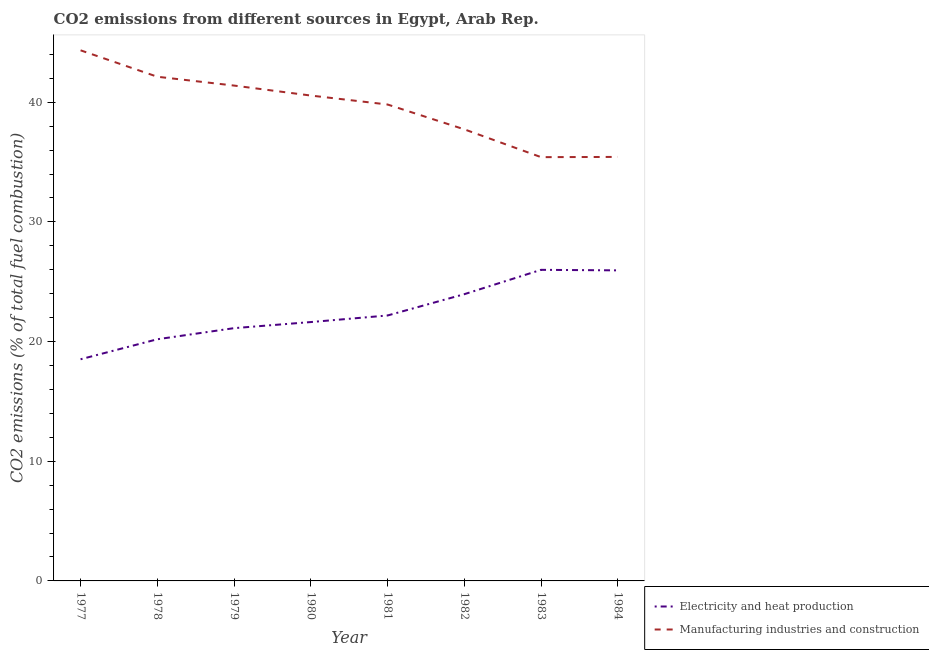Is the number of lines equal to the number of legend labels?
Offer a very short reply. Yes. What is the co2 emissions due to manufacturing industries in 1984?
Give a very brief answer. 35.43. Across all years, what is the maximum co2 emissions due to manufacturing industries?
Make the answer very short. 44.34. Across all years, what is the minimum co2 emissions due to electricity and heat production?
Your answer should be compact. 18.52. In which year was the co2 emissions due to manufacturing industries maximum?
Keep it short and to the point. 1977. What is the total co2 emissions due to electricity and heat production in the graph?
Your answer should be very brief. 179.56. What is the difference between the co2 emissions due to electricity and heat production in 1979 and that in 1982?
Your answer should be very brief. -2.84. What is the difference between the co2 emissions due to electricity and heat production in 1979 and the co2 emissions due to manufacturing industries in 1978?
Give a very brief answer. -21.01. What is the average co2 emissions due to manufacturing industries per year?
Your answer should be compact. 39.6. In the year 1978, what is the difference between the co2 emissions due to electricity and heat production and co2 emissions due to manufacturing industries?
Your answer should be very brief. -21.94. In how many years, is the co2 emissions due to electricity and heat production greater than 36 %?
Keep it short and to the point. 0. What is the ratio of the co2 emissions due to manufacturing industries in 1977 to that in 1979?
Keep it short and to the point. 1.07. Is the difference between the co2 emissions due to manufacturing industries in 1977 and 1978 greater than the difference between the co2 emissions due to electricity and heat production in 1977 and 1978?
Provide a short and direct response. Yes. What is the difference between the highest and the second highest co2 emissions due to electricity and heat production?
Make the answer very short. 0.04. What is the difference between the highest and the lowest co2 emissions due to electricity and heat production?
Make the answer very short. 7.47. In how many years, is the co2 emissions due to manufacturing industries greater than the average co2 emissions due to manufacturing industries taken over all years?
Give a very brief answer. 5. Is the sum of the co2 emissions due to electricity and heat production in 1977 and 1983 greater than the maximum co2 emissions due to manufacturing industries across all years?
Give a very brief answer. Yes. Does the co2 emissions due to manufacturing industries monotonically increase over the years?
Provide a short and direct response. No. Is the co2 emissions due to electricity and heat production strictly greater than the co2 emissions due to manufacturing industries over the years?
Offer a very short reply. No. How many lines are there?
Give a very brief answer. 2. How many years are there in the graph?
Your answer should be very brief. 8. What is the difference between two consecutive major ticks on the Y-axis?
Your answer should be compact. 10. Are the values on the major ticks of Y-axis written in scientific E-notation?
Your answer should be compact. No. Where does the legend appear in the graph?
Offer a very short reply. Bottom right. How are the legend labels stacked?
Your answer should be very brief. Vertical. What is the title of the graph?
Ensure brevity in your answer.  CO2 emissions from different sources in Egypt, Arab Rep. Does "Highest 20% of population" appear as one of the legend labels in the graph?
Give a very brief answer. No. What is the label or title of the Y-axis?
Provide a short and direct response. CO2 emissions (% of total fuel combustion). What is the CO2 emissions (% of total fuel combustion) in Electricity and heat production in 1977?
Your response must be concise. 18.52. What is the CO2 emissions (% of total fuel combustion) in Manufacturing industries and construction in 1977?
Your answer should be compact. 44.34. What is the CO2 emissions (% of total fuel combustion) of Electricity and heat production in 1978?
Your answer should be very brief. 20.19. What is the CO2 emissions (% of total fuel combustion) in Manufacturing industries and construction in 1978?
Your answer should be very brief. 42.13. What is the CO2 emissions (% of total fuel combustion) of Electricity and heat production in 1979?
Keep it short and to the point. 21.12. What is the CO2 emissions (% of total fuel combustion) in Manufacturing industries and construction in 1979?
Offer a very short reply. 41.39. What is the CO2 emissions (% of total fuel combustion) in Electricity and heat production in 1980?
Give a very brief answer. 21.63. What is the CO2 emissions (% of total fuel combustion) of Manufacturing industries and construction in 1980?
Your answer should be compact. 40.56. What is the CO2 emissions (% of total fuel combustion) in Electricity and heat production in 1981?
Your answer should be very brief. 22.18. What is the CO2 emissions (% of total fuel combustion) of Manufacturing industries and construction in 1981?
Provide a succinct answer. 39.81. What is the CO2 emissions (% of total fuel combustion) in Electricity and heat production in 1982?
Provide a short and direct response. 23.96. What is the CO2 emissions (% of total fuel combustion) in Manufacturing industries and construction in 1982?
Ensure brevity in your answer.  37.74. What is the CO2 emissions (% of total fuel combustion) in Electricity and heat production in 1983?
Ensure brevity in your answer.  26. What is the CO2 emissions (% of total fuel combustion) of Manufacturing industries and construction in 1983?
Keep it short and to the point. 35.41. What is the CO2 emissions (% of total fuel combustion) in Electricity and heat production in 1984?
Your answer should be compact. 25.95. What is the CO2 emissions (% of total fuel combustion) of Manufacturing industries and construction in 1984?
Make the answer very short. 35.43. Across all years, what is the maximum CO2 emissions (% of total fuel combustion) in Electricity and heat production?
Provide a succinct answer. 26. Across all years, what is the maximum CO2 emissions (% of total fuel combustion) in Manufacturing industries and construction?
Keep it short and to the point. 44.34. Across all years, what is the minimum CO2 emissions (% of total fuel combustion) in Electricity and heat production?
Offer a very short reply. 18.52. Across all years, what is the minimum CO2 emissions (% of total fuel combustion) of Manufacturing industries and construction?
Provide a short and direct response. 35.41. What is the total CO2 emissions (% of total fuel combustion) in Electricity and heat production in the graph?
Your answer should be very brief. 179.56. What is the total CO2 emissions (% of total fuel combustion) of Manufacturing industries and construction in the graph?
Make the answer very short. 316.82. What is the difference between the CO2 emissions (% of total fuel combustion) of Electricity and heat production in 1977 and that in 1978?
Give a very brief answer. -1.67. What is the difference between the CO2 emissions (% of total fuel combustion) in Manufacturing industries and construction in 1977 and that in 1978?
Offer a very short reply. 2.21. What is the difference between the CO2 emissions (% of total fuel combustion) in Electricity and heat production in 1977 and that in 1979?
Offer a terse response. -2.6. What is the difference between the CO2 emissions (% of total fuel combustion) of Manufacturing industries and construction in 1977 and that in 1979?
Offer a very short reply. 2.95. What is the difference between the CO2 emissions (% of total fuel combustion) in Electricity and heat production in 1977 and that in 1980?
Offer a terse response. -3.11. What is the difference between the CO2 emissions (% of total fuel combustion) of Manufacturing industries and construction in 1977 and that in 1980?
Give a very brief answer. 3.78. What is the difference between the CO2 emissions (% of total fuel combustion) in Electricity and heat production in 1977 and that in 1981?
Your answer should be very brief. -3.66. What is the difference between the CO2 emissions (% of total fuel combustion) in Manufacturing industries and construction in 1977 and that in 1981?
Ensure brevity in your answer.  4.53. What is the difference between the CO2 emissions (% of total fuel combustion) of Electricity and heat production in 1977 and that in 1982?
Ensure brevity in your answer.  -5.44. What is the difference between the CO2 emissions (% of total fuel combustion) in Manufacturing industries and construction in 1977 and that in 1982?
Give a very brief answer. 6.6. What is the difference between the CO2 emissions (% of total fuel combustion) in Electricity and heat production in 1977 and that in 1983?
Your answer should be compact. -7.47. What is the difference between the CO2 emissions (% of total fuel combustion) in Manufacturing industries and construction in 1977 and that in 1983?
Give a very brief answer. 8.93. What is the difference between the CO2 emissions (% of total fuel combustion) of Electricity and heat production in 1977 and that in 1984?
Your answer should be very brief. -7.43. What is the difference between the CO2 emissions (% of total fuel combustion) in Manufacturing industries and construction in 1977 and that in 1984?
Keep it short and to the point. 8.91. What is the difference between the CO2 emissions (% of total fuel combustion) of Electricity and heat production in 1978 and that in 1979?
Offer a terse response. -0.93. What is the difference between the CO2 emissions (% of total fuel combustion) in Manufacturing industries and construction in 1978 and that in 1979?
Provide a succinct answer. 0.74. What is the difference between the CO2 emissions (% of total fuel combustion) in Electricity and heat production in 1978 and that in 1980?
Make the answer very short. -1.44. What is the difference between the CO2 emissions (% of total fuel combustion) in Manufacturing industries and construction in 1978 and that in 1980?
Keep it short and to the point. 1.57. What is the difference between the CO2 emissions (% of total fuel combustion) of Electricity and heat production in 1978 and that in 1981?
Ensure brevity in your answer.  -1.99. What is the difference between the CO2 emissions (% of total fuel combustion) of Manufacturing industries and construction in 1978 and that in 1981?
Provide a short and direct response. 2.32. What is the difference between the CO2 emissions (% of total fuel combustion) in Electricity and heat production in 1978 and that in 1982?
Your answer should be very brief. -3.77. What is the difference between the CO2 emissions (% of total fuel combustion) of Manufacturing industries and construction in 1978 and that in 1982?
Give a very brief answer. 4.4. What is the difference between the CO2 emissions (% of total fuel combustion) of Electricity and heat production in 1978 and that in 1983?
Give a very brief answer. -5.8. What is the difference between the CO2 emissions (% of total fuel combustion) in Manufacturing industries and construction in 1978 and that in 1983?
Offer a very short reply. 6.72. What is the difference between the CO2 emissions (% of total fuel combustion) in Electricity and heat production in 1978 and that in 1984?
Give a very brief answer. -5.76. What is the difference between the CO2 emissions (% of total fuel combustion) in Manufacturing industries and construction in 1978 and that in 1984?
Your response must be concise. 6.7. What is the difference between the CO2 emissions (% of total fuel combustion) in Electricity and heat production in 1979 and that in 1980?
Your response must be concise. -0.51. What is the difference between the CO2 emissions (% of total fuel combustion) in Manufacturing industries and construction in 1979 and that in 1980?
Make the answer very short. 0.83. What is the difference between the CO2 emissions (% of total fuel combustion) of Electricity and heat production in 1979 and that in 1981?
Offer a very short reply. -1.06. What is the difference between the CO2 emissions (% of total fuel combustion) of Manufacturing industries and construction in 1979 and that in 1981?
Give a very brief answer. 1.58. What is the difference between the CO2 emissions (% of total fuel combustion) of Electricity and heat production in 1979 and that in 1982?
Offer a terse response. -2.84. What is the difference between the CO2 emissions (% of total fuel combustion) of Manufacturing industries and construction in 1979 and that in 1982?
Your answer should be very brief. 3.66. What is the difference between the CO2 emissions (% of total fuel combustion) in Electricity and heat production in 1979 and that in 1983?
Your answer should be very brief. -4.87. What is the difference between the CO2 emissions (% of total fuel combustion) of Manufacturing industries and construction in 1979 and that in 1983?
Make the answer very short. 5.98. What is the difference between the CO2 emissions (% of total fuel combustion) of Electricity and heat production in 1979 and that in 1984?
Offer a terse response. -4.83. What is the difference between the CO2 emissions (% of total fuel combustion) of Manufacturing industries and construction in 1979 and that in 1984?
Offer a very short reply. 5.96. What is the difference between the CO2 emissions (% of total fuel combustion) in Electricity and heat production in 1980 and that in 1981?
Provide a succinct answer. -0.55. What is the difference between the CO2 emissions (% of total fuel combustion) in Manufacturing industries and construction in 1980 and that in 1981?
Ensure brevity in your answer.  0.75. What is the difference between the CO2 emissions (% of total fuel combustion) in Electricity and heat production in 1980 and that in 1982?
Offer a very short reply. -2.33. What is the difference between the CO2 emissions (% of total fuel combustion) in Manufacturing industries and construction in 1980 and that in 1982?
Give a very brief answer. 2.82. What is the difference between the CO2 emissions (% of total fuel combustion) of Electricity and heat production in 1980 and that in 1983?
Offer a terse response. -4.36. What is the difference between the CO2 emissions (% of total fuel combustion) in Manufacturing industries and construction in 1980 and that in 1983?
Give a very brief answer. 5.15. What is the difference between the CO2 emissions (% of total fuel combustion) of Electricity and heat production in 1980 and that in 1984?
Provide a short and direct response. -4.32. What is the difference between the CO2 emissions (% of total fuel combustion) of Manufacturing industries and construction in 1980 and that in 1984?
Provide a succinct answer. 5.13. What is the difference between the CO2 emissions (% of total fuel combustion) in Electricity and heat production in 1981 and that in 1982?
Provide a short and direct response. -1.78. What is the difference between the CO2 emissions (% of total fuel combustion) in Manufacturing industries and construction in 1981 and that in 1982?
Give a very brief answer. 2.07. What is the difference between the CO2 emissions (% of total fuel combustion) in Electricity and heat production in 1981 and that in 1983?
Your response must be concise. -3.81. What is the difference between the CO2 emissions (% of total fuel combustion) of Manufacturing industries and construction in 1981 and that in 1983?
Provide a succinct answer. 4.4. What is the difference between the CO2 emissions (% of total fuel combustion) of Electricity and heat production in 1981 and that in 1984?
Ensure brevity in your answer.  -3.77. What is the difference between the CO2 emissions (% of total fuel combustion) of Manufacturing industries and construction in 1981 and that in 1984?
Provide a succinct answer. 4.38. What is the difference between the CO2 emissions (% of total fuel combustion) of Electricity and heat production in 1982 and that in 1983?
Your response must be concise. -2.03. What is the difference between the CO2 emissions (% of total fuel combustion) of Manufacturing industries and construction in 1982 and that in 1983?
Provide a short and direct response. 2.32. What is the difference between the CO2 emissions (% of total fuel combustion) in Electricity and heat production in 1982 and that in 1984?
Ensure brevity in your answer.  -1.99. What is the difference between the CO2 emissions (% of total fuel combustion) of Manufacturing industries and construction in 1982 and that in 1984?
Ensure brevity in your answer.  2.31. What is the difference between the CO2 emissions (% of total fuel combustion) of Electricity and heat production in 1983 and that in 1984?
Offer a terse response. 0.04. What is the difference between the CO2 emissions (% of total fuel combustion) in Manufacturing industries and construction in 1983 and that in 1984?
Give a very brief answer. -0.02. What is the difference between the CO2 emissions (% of total fuel combustion) of Electricity and heat production in 1977 and the CO2 emissions (% of total fuel combustion) of Manufacturing industries and construction in 1978?
Keep it short and to the point. -23.61. What is the difference between the CO2 emissions (% of total fuel combustion) of Electricity and heat production in 1977 and the CO2 emissions (% of total fuel combustion) of Manufacturing industries and construction in 1979?
Give a very brief answer. -22.87. What is the difference between the CO2 emissions (% of total fuel combustion) in Electricity and heat production in 1977 and the CO2 emissions (% of total fuel combustion) in Manufacturing industries and construction in 1980?
Offer a terse response. -22.04. What is the difference between the CO2 emissions (% of total fuel combustion) in Electricity and heat production in 1977 and the CO2 emissions (% of total fuel combustion) in Manufacturing industries and construction in 1981?
Provide a succinct answer. -21.29. What is the difference between the CO2 emissions (% of total fuel combustion) of Electricity and heat production in 1977 and the CO2 emissions (% of total fuel combustion) of Manufacturing industries and construction in 1982?
Provide a short and direct response. -19.21. What is the difference between the CO2 emissions (% of total fuel combustion) of Electricity and heat production in 1977 and the CO2 emissions (% of total fuel combustion) of Manufacturing industries and construction in 1983?
Your answer should be compact. -16.89. What is the difference between the CO2 emissions (% of total fuel combustion) of Electricity and heat production in 1977 and the CO2 emissions (% of total fuel combustion) of Manufacturing industries and construction in 1984?
Make the answer very short. -16.91. What is the difference between the CO2 emissions (% of total fuel combustion) of Electricity and heat production in 1978 and the CO2 emissions (% of total fuel combustion) of Manufacturing industries and construction in 1979?
Your response must be concise. -21.2. What is the difference between the CO2 emissions (% of total fuel combustion) in Electricity and heat production in 1978 and the CO2 emissions (% of total fuel combustion) in Manufacturing industries and construction in 1980?
Your answer should be compact. -20.36. What is the difference between the CO2 emissions (% of total fuel combustion) in Electricity and heat production in 1978 and the CO2 emissions (% of total fuel combustion) in Manufacturing industries and construction in 1981?
Your response must be concise. -19.62. What is the difference between the CO2 emissions (% of total fuel combustion) in Electricity and heat production in 1978 and the CO2 emissions (% of total fuel combustion) in Manufacturing industries and construction in 1982?
Provide a succinct answer. -17.54. What is the difference between the CO2 emissions (% of total fuel combustion) of Electricity and heat production in 1978 and the CO2 emissions (% of total fuel combustion) of Manufacturing industries and construction in 1983?
Offer a terse response. -15.22. What is the difference between the CO2 emissions (% of total fuel combustion) in Electricity and heat production in 1978 and the CO2 emissions (% of total fuel combustion) in Manufacturing industries and construction in 1984?
Keep it short and to the point. -15.24. What is the difference between the CO2 emissions (% of total fuel combustion) in Electricity and heat production in 1979 and the CO2 emissions (% of total fuel combustion) in Manufacturing industries and construction in 1980?
Provide a short and direct response. -19.44. What is the difference between the CO2 emissions (% of total fuel combustion) in Electricity and heat production in 1979 and the CO2 emissions (% of total fuel combustion) in Manufacturing industries and construction in 1981?
Provide a short and direct response. -18.69. What is the difference between the CO2 emissions (% of total fuel combustion) in Electricity and heat production in 1979 and the CO2 emissions (% of total fuel combustion) in Manufacturing industries and construction in 1982?
Provide a succinct answer. -16.61. What is the difference between the CO2 emissions (% of total fuel combustion) in Electricity and heat production in 1979 and the CO2 emissions (% of total fuel combustion) in Manufacturing industries and construction in 1983?
Your answer should be compact. -14.29. What is the difference between the CO2 emissions (% of total fuel combustion) in Electricity and heat production in 1979 and the CO2 emissions (% of total fuel combustion) in Manufacturing industries and construction in 1984?
Provide a succinct answer. -14.31. What is the difference between the CO2 emissions (% of total fuel combustion) in Electricity and heat production in 1980 and the CO2 emissions (% of total fuel combustion) in Manufacturing industries and construction in 1981?
Provide a short and direct response. -18.18. What is the difference between the CO2 emissions (% of total fuel combustion) of Electricity and heat production in 1980 and the CO2 emissions (% of total fuel combustion) of Manufacturing industries and construction in 1982?
Offer a very short reply. -16.1. What is the difference between the CO2 emissions (% of total fuel combustion) of Electricity and heat production in 1980 and the CO2 emissions (% of total fuel combustion) of Manufacturing industries and construction in 1983?
Your response must be concise. -13.78. What is the difference between the CO2 emissions (% of total fuel combustion) in Electricity and heat production in 1980 and the CO2 emissions (% of total fuel combustion) in Manufacturing industries and construction in 1984?
Make the answer very short. -13.8. What is the difference between the CO2 emissions (% of total fuel combustion) in Electricity and heat production in 1981 and the CO2 emissions (% of total fuel combustion) in Manufacturing industries and construction in 1982?
Your answer should be very brief. -15.56. What is the difference between the CO2 emissions (% of total fuel combustion) of Electricity and heat production in 1981 and the CO2 emissions (% of total fuel combustion) of Manufacturing industries and construction in 1983?
Keep it short and to the point. -13.23. What is the difference between the CO2 emissions (% of total fuel combustion) of Electricity and heat production in 1981 and the CO2 emissions (% of total fuel combustion) of Manufacturing industries and construction in 1984?
Provide a short and direct response. -13.25. What is the difference between the CO2 emissions (% of total fuel combustion) of Electricity and heat production in 1982 and the CO2 emissions (% of total fuel combustion) of Manufacturing industries and construction in 1983?
Your answer should be compact. -11.45. What is the difference between the CO2 emissions (% of total fuel combustion) in Electricity and heat production in 1982 and the CO2 emissions (% of total fuel combustion) in Manufacturing industries and construction in 1984?
Your answer should be very brief. -11.47. What is the difference between the CO2 emissions (% of total fuel combustion) in Electricity and heat production in 1983 and the CO2 emissions (% of total fuel combustion) in Manufacturing industries and construction in 1984?
Make the answer very short. -9.44. What is the average CO2 emissions (% of total fuel combustion) in Electricity and heat production per year?
Your response must be concise. 22.45. What is the average CO2 emissions (% of total fuel combustion) of Manufacturing industries and construction per year?
Give a very brief answer. 39.6. In the year 1977, what is the difference between the CO2 emissions (% of total fuel combustion) in Electricity and heat production and CO2 emissions (% of total fuel combustion) in Manufacturing industries and construction?
Keep it short and to the point. -25.82. In the year 1978, what is the difference between the CO2 emissions (% of total fuel combustion) in Electricity and heat production and CO2 emissions (% of total fuel combustion) in Manufacturing industries and construction?
Keep it short and to the point. -21.94. In the year 1979, what is the difference between the CO2 emissions (% of total fuel combustion) in Electricity and heat production and CO2 emissions (% of total fuel combustion) in Manufacturing industries and construction?
Keep it short and to the point. -20.27. In the year 1980, what is the difference between the CO2 emissions (% of total fuel combustion) in Electricity and heat production and CO2 emissions (% of total fuel combustion) in Manufacturing industries and construction?
Your answer should be very brief. -18.93. In the year 1981, what is the difference between the CO2 emissions (% of total fuel combustion) of Electricity and heat production and CO2 emissions (% of total fuel combustion) of Manufacturing industries and construction?
Provide a short and direct response. -17.63. In the year 1982, what is the difference between the CO2 emissions (% of total fuel combustion) of Electricity and heat production and CO2 emissions (% of total fuel combustion) of Manufacturing industries and construction?
Your answer should be very brief. -13.78. In the year 1983, what is the difference between the CO2 emissions (% of total fuel combustion) in Electricity and heat production and CO2 emissions (% of total fuel combustion) in Manufacturing industries and construction?
Your response must be concise. -9.42. In the year 1984, what is the difference between the CO2 emissions (% of total fuel combustion) in Electricity and heat production and CO2 emissions (% of total fuel combustion) in Manufacturing industries and construction?
Give a very brief answer. -9.48. What is the ratio of the CO2 emissions (% of total fuel combustion) of Electricity and heat production in 1977 to that in 1978?
Provide a succinct answer. 0.92. What is the ratio of the CO2 emissions (% of total fuel combustion) in Manufacturing industries and construction in 1977 to that in 1978?
Make the answer very short. 1.05. What is the ratio of the CO2 emissions (% of total fuel combustion) in Electricity and heat production in 1977 to that in 1979?
Keep it short and to the point. 0.88. What is the ratio of the CO2 emissions (% of total fuel combustion) of Manufacturing industries and construction in 1977 to that in 1979?
Give a very brief answer. 1.07. What is the ratio of the CO2 emissions (% of total fuel combustion) in Electricity and heat production in 1977 to that in 1980?
Give a very brief answer. 0.86. What is the ratio of the CO2 emissions (% of total fuel combustion) of Manufacturing industries and construction in 1977 to that in 1980?
Your response must be concise. 1.09. What is the ratio of the CO2 emissions (% of total fuel combustion) in Electricity and heat production in 1977 to that in 1981?
Provide a succinct answer. 0.84. What is the ratio of the CO2 emissions (% of total fuel combustion) of Manufacturing industries and construction in 1977 to that in 1981?
Make the answer very short. 1.11. What is the ratio of the CO2 emissions (% of total fuel combustion) of Electricity and heat production in 1977 to that in 1982?
Give a very brief answer. 0.77. What is the ratio of the CO2 emissions (% of total fuel combustion) of Manufacturing industries and construction in 1977 to that in 1982?
Offer a terse response. 1.18. What is the ratio of the CO2 emissions (% of total fuel combustion) of Electricity and heat production in 1977 to that in 1983?
Ensure brevity in your answer.  0.71. What is the ratio of the CO2 emissions (% of total fuel combustion) in Manufacturing industries and construction in 1977 to that in 1983?
Give a very brief answer. 1.25. What is the ratio of the CO2 emissions (% of total fuel combustion) in Electricity and heat production in 1977 to that in 1984?
Give a very brief answer. 0.71. What is the ratio of the CO2 emissions (% of total fuel combustion) of Manufacturing industries and construction in 1977 to that in 1984?
Make the answer very short. 1.25. What is the ratio of the CO2 emissions (% of total fuel combustion) in Electricity and heat production in 1978 to that in 1979?
Keep it short and to the point. 0.96. What is the ratio of the CO2 emissions (% of total fuel combustion) in Manufacturing industries and construction in 1978 to that in 1979?
Offer a terse response. 1.02. What is the ratio of the CO2 emissions (% of total fuel combustion) of Electricity and heat production in 1978 to that in 1980?
Your answer should be compact. 0.93. What is the ratio of the CO2 emissions (% of total fuel combustion) in Manufacturing industries and construction in 1978 to that in 1980?
Give a very brief answer. 1.04. What is the ratio of the CO2 emissions (% of total fuel combustion) in Electricity and heat production in 1978 to that in 1981?
Keep it short and to the point. 0.91. What is the ratio of the CO2 emissions (% of total fuel combustion) in Manufacturing industries and construction in 1978 to that in 1981?
Offer a very short reply. 1.06. What is the ratio of the CO2 emissions (% of total fuel combustion) in Electricity and heat production in 1978 to that in 1982?
Keep it short and to the point. 0.84. What is the ratio of the CO2 emissions (% of total fuel combustion) of Manufacturing industries and construction in 1978 to that in 1982?
Your response must be concise. 1.12. What is the ratio of the CO2 emissions (% of total fuel combustion) of Electricity and heat production in 1978 to that in 1983?
Provide a succinct answer. 0.78. What is the ratio of the CO2 emissions (% of total fuel combustion) in Manufacturing industries and construction in 1978 to that in 1983?
Your answer should be compact. 1.19. What is the ratio of the CO2 emissions (% of total fuel combustion) of Electricity and heat production in 1978 to that in 1984?
Give a very brief answer. 0.78. What is the ratio of the CO2 emissions (% of total fuel combustion) in Manufacturing industries and construction in 1978 to that in 1984?
Your answer should be compact. 1.19. What is the ratio of the CO2 emissions (% of total fuel combustion) in Electricity and heat production in 1979 to that in 1980?
Your answer should be compact. 0.98. What is the ratio of the CO2 emissions (% of total fuel combustion) in Manufacturing industries and construction in 1979 to that in 1980?
Provide a succinct answer. 1.02. What is the ratio of the CO2 emissions (% of total fuel combustion) of Electricity and heat production in 1979 to that in 1981?
Provide a short and direct response. 0.95. What is the ratio of the CO2 emissions (% of total fuel combustion) in Manufacturing industries and construction in 1979 to that in 1981?
Offer a very short reply. 1.04. What is the ratio of the CO2 emissions (% of total fuel combustion) of Electricity and heat production in 1979 to that in 1982?
Provide a succinct answer. 0.88. What is the ratio of the CO2 emissions (% of total fuel combustion) in Manufacturing industries and construction in 1979 to that in 1982?
Your response must be concise. 1.1. What is the ratio of the CO2 emissions (% of total fuel combustion) in Electricity and heat production in 1979 to that in 1983?
Your answer should be very brief. 0.81. What is the ratio of the CO2 emissions (% of total fuel combustion) of Manufacturing industries and construction in 1979 to that in 1983?
Offer a terse response. 1.17. What is the ratio of the CO2 emissions (% of total fuel combustion) of Electricity and heat production in 1979 to that in 1984?
Ensure brevity in your answer.  0.81. What is the ratio of the CO2 emissions (% of total fuel combustion) in Manufacturing industries and construction in 1979 to that in 1984?
Offer a terse response. 1.17. What is the ratio of the CO2 emissions (% of total fuel combustion) in Electricity and heat production in 1980 to that in 1981?
Provide a succinct answer. 0.98. What is the ratio of the CO2 emissions (% of total fuel combustion) in Manufacturing industries and construction in 1980 to that in 1981?
Provide a short and direct response. 1.02. What is the ratio of the CO2 emissions (% of total fuel combustion) in Electricity and heat production in 1980 to that in 1982?
Offer a terse response. 0.9. What is the ratio of the CO2 emissions (% of total fuel combustion) in Manufacturing industries and construction in 1980 to that in 1982?
Your answer should be very brief. 1.07. What is the ratio of the CO2 emissions (% of total fuel combustion) of Electricity and heat production in 1980 to that in 1983?
Provide a succinct answer. 0.83. What is the ratio of the CO2 emissions (% of total fuel combustion) of Manufacturing industries and construction in 1980 to that in 1983?
Offer a terse response. 1.15. What is the ratio of the CO2 emissions (% of total fuel combustion) of Electricity and heat production in 1980 to that in 1984?
Keep it short and to the point. 0.83. What is the ratio of the CO2 emissions (% of total fuel combustion) of Manufacturing industries and construction in 1980 to that in 1984?
Ensure brevity in your answer.  1.14. What is the ratio of the CO2 emissions (% of total fuel combustion) in Electricity and heat production in 1981 to that in 1982?
Give a very brief answer. 0.93. What is the ratio of the CO2 emissions (% of total fuel combustion) in Manufacturing industries and construction in 1981 to that in 1982?
Offer a terse response. 1.05. What is the ratio of the CO2 emissions (% of total fuel combustion) of Electricity and heat production in 1981 to that in 1983?
Your answer should be compact. 0.85. What is the ratio of the CO2 emissions (% of total fuel combustion) of Manufacturing industries and construction in 1981 to that in 1983?
Your response must be concise. 1.12. What is the ratio of the CO2 emissions (% of total fuel combustion) in Electricity and heat production in 1981 to that in 1984?
Your response must be concise. 0.85. What is the ratio of the CO2 emissions (% of total fuel combustion) in Manufacturing industries and construction in 1981 to that in 1984?
Give a very brief answer. 1.12. What is the ratio of the CO2 emissions (% of total fuel combustion) of Electricity and heat production in 1982 to that in 1983?
Your answer should be very brief. 0.92. What is the ratio of the CO2 emissions (% of total fuel combustion) of Manufacturing industries and construction in 1982 to that in 1983?
Offer a terse response. 1.07. What is the ratio of the CO2 emissions (% of total fuel combustion) of Electricity and heat production in 1982 to that in 1984?
Offer a very short reply. 0.92. What is the ratio of the CO2 emissions (% of total fuel combustion) in Manufacturing industries and construction in 1982 to that in 1984?
Make the answer very short. 1.07. What is the difference between the highest and the second highest CO2 emissions (% of total fuel combustion) in Electricity and heat production?
Ensure brevity in your answer.  0.04. What is the difference between the highest and the second highest CO2 emissions (% of total fuel combustion) of Manufacturing industries and construction?
Ensure brevity in your answer.  2.21. What is the difference between the highest and the lowest CO2 emissions (% of total fuel combustion) of Electricity and heat production?
Give a very brief answer. 7.47. What is the difference between the highest and the lowest CO2 emissions (% of total fuel combustion) of Manufacturing industries and construction?
Your answer should be very brief. 8.93. 